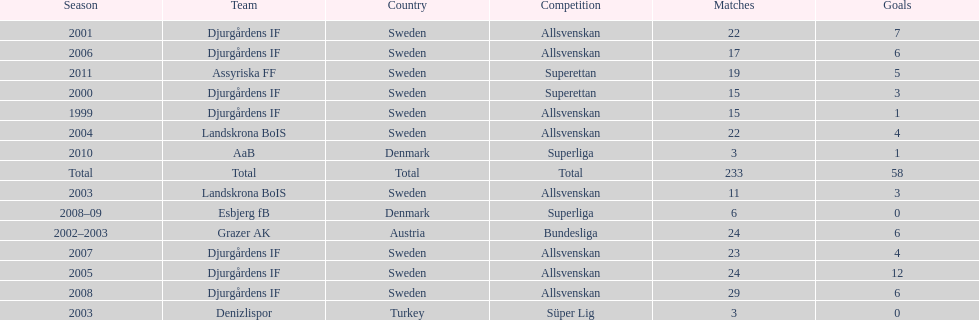How many matches did jones kusi-asare play in in his first season? 15. Could you parse the entire table as a dict? {'header': ['Season', 'Team', 'Country', 'Competition', 'Matches', 'Goals'], 'rows': [['2001', 'Djurgårdens IF', 'Sweden', 'Allsvenskan', '22', '7'], ['2006', 'Djurgårdens IF', 'Sweden', 'Allsvenskan', '17', '6'], ['2011', 'Assyriska FF', 'Sweden', 'Superettan', '19', '5'], ['2000', 'Djurgårdens IF', 'Sweden', 'Superettan', '15', '3'], ['1999', 'Djurgårdens IF', 'Sweden', 'Allsvenskan', '15', '1'], ['2004', 'Landskrona BoIS', 'Sweden', 'Allsvenskan', '22', '4'], ['2010', 'AaB', 'Denmark', 'Superliga', '3', '1'], ['Total', 'Total', 'Total', 'Total', '233', '58'], ['2003', 'Landskrona BoIS', 'Sweden', 'Allsvenskan', '11', '3'], ['2008–09', 'Esbjerg fB', 'Denmark', 'Superliga', '6', '0'], ['2002–2003', 'Grazer AK', 'Austria', 'Bundesliga', '24', '6'], ['2007', 'Djurgårdens IF', 'Sweden', 'Allsvenskan', '23', '4'], ['2005', 'Djurgårdens IF', 'Sweden', 'Allsvenskan', '24', '12'], ['2008', 'Djurgårdens IF', 'Sweden', 'Allsvenskan', '29', '6'], ['2003', 'Denizlispor', 'Turkey', 'Süper Lig', '3', '0']]} 